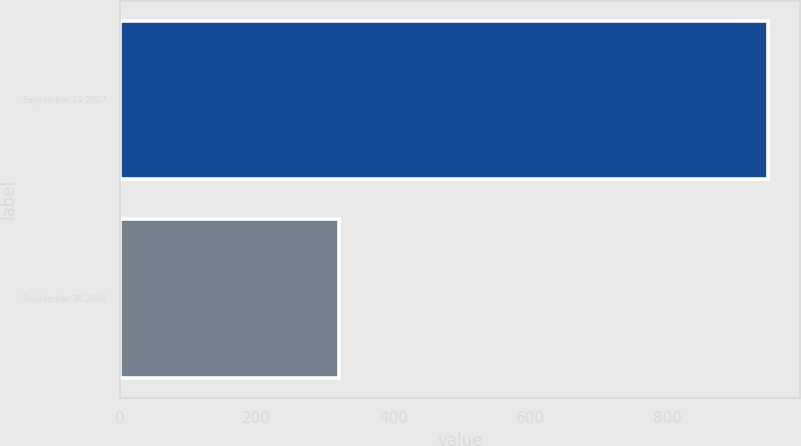Convert chart. <chart><loc_0><loc_0><loc_500><loc_500><bar_chart><fcel>September 29 2007<fcel>September 30 2006<nl><fcel>947<fcel>320<nl></chart> 